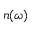<formula> <loc_0><loc_0><loc_500><loc_500>n ( \omega )</formula> 